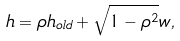<formula> <loc_0><loc_0><loc_500><loc_500>h = \rho h _ { o l d } + \sqrt { 1 - \rho ^ { 2 } } w ,</formula> 